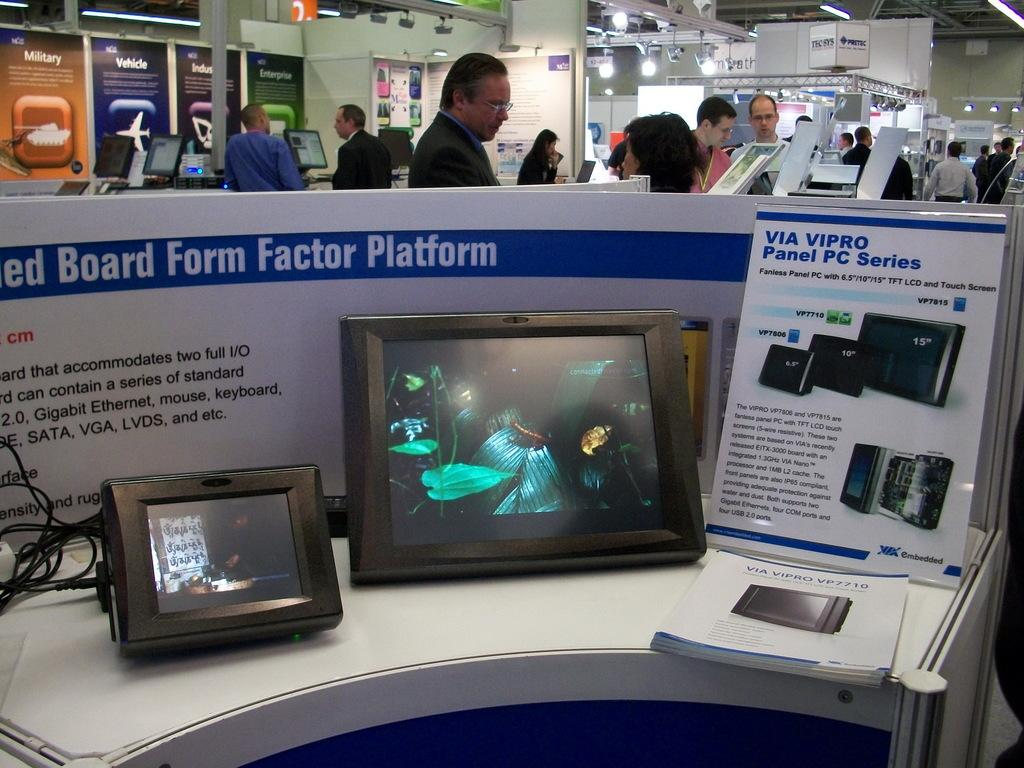<image>
Present a compact description of the photo's key features. A booth at a technology convention advertises the Via Vipro Panel PC Series. 